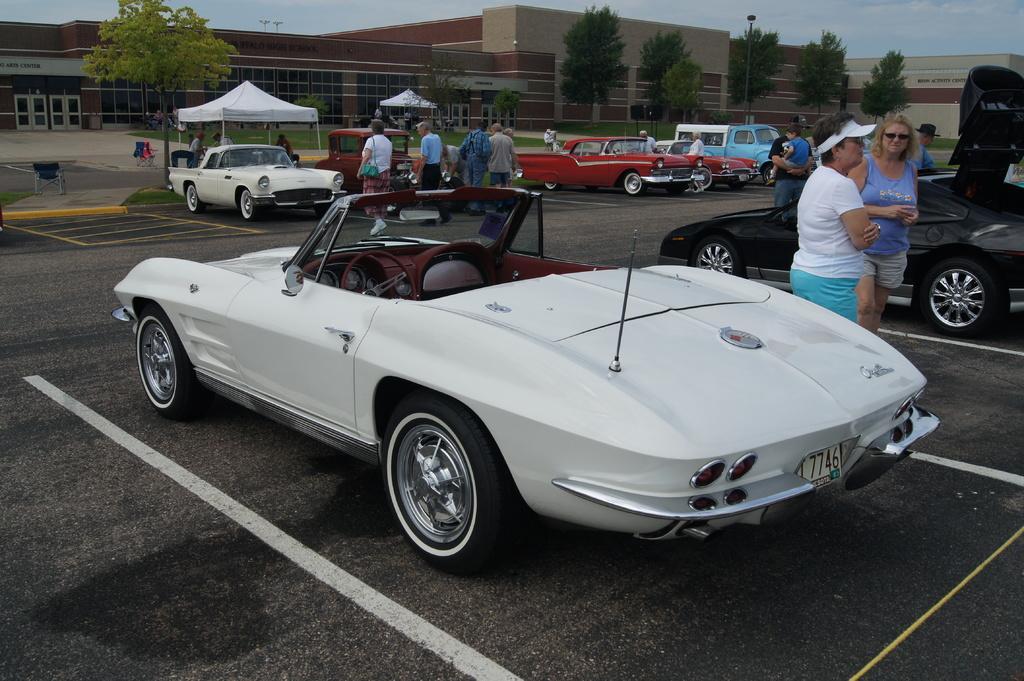Please provide a concise description of this image. In this image I can see few vehicles, in front the vehicle is in white color. Background I can see few persons standing, buildings in brown and cream color, trees in green color and sky in blue and white color. 